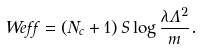<formula> <loc_0><loc_0><loc_500><loc_500>\ W e f f = \left ( N _ { c } + 1 \right ) S \log { \frac { \lambda \Lambda ^ { 2 } } { m } } .</formula> 